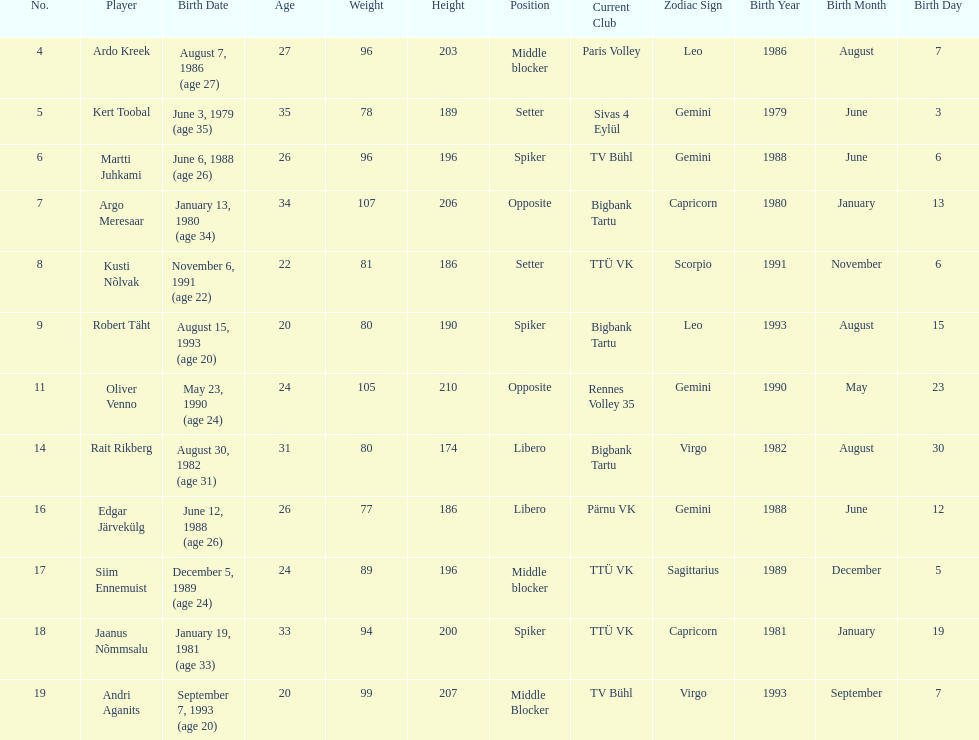Who is at least 25 years or older? Ardo Kreek, Kert Toobal, Martti Juhkami, Argo Meresaar, Rait Rikberg, Edgar Järvekülg, Jaanus Nõmmsalu. 